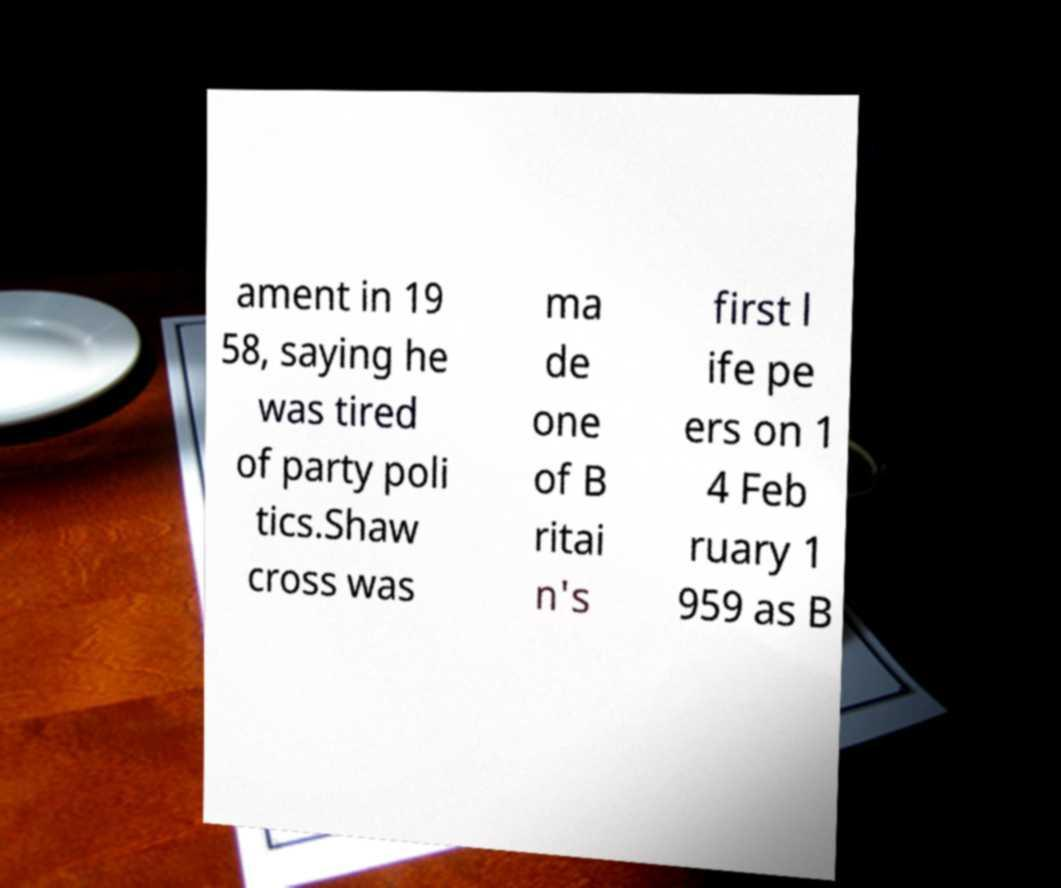Could you assist in decoding the text presented in this image and type it out clearly? ament in 19 58, saying he was tired of party poli tics.Shaw cross was ma de one of B ritai n's first l ife pe ers on 1 4 Feb ruary 1 959 as B 